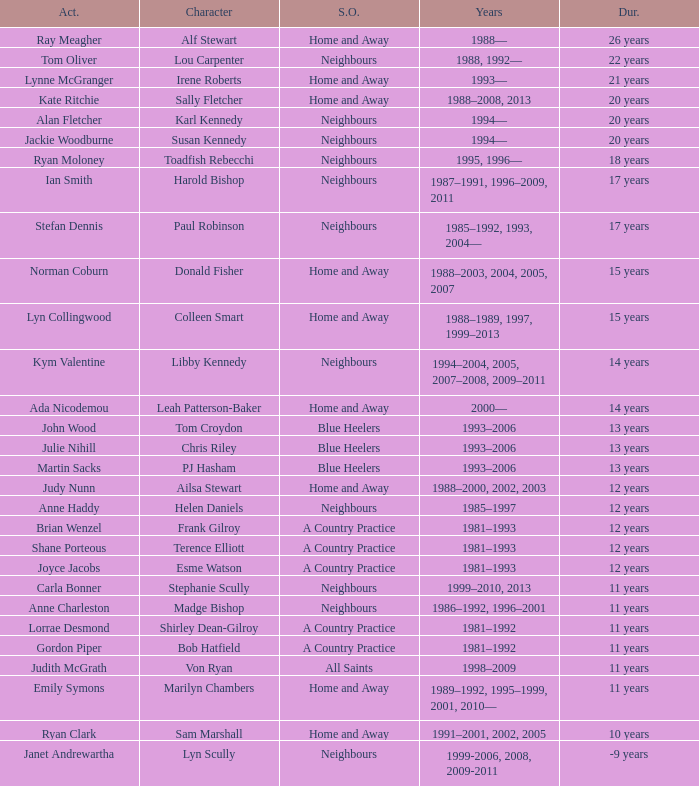Which years did Martin Sacks work on a soap opera? 1993–2006. 